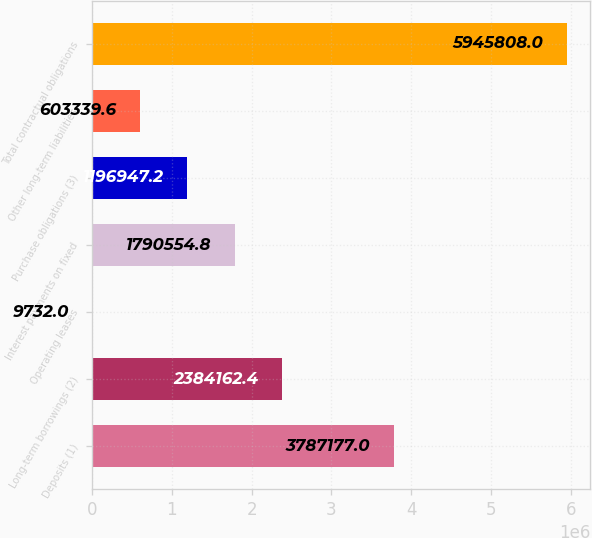Convert chart to OTSL. <chart><loc_0><loc_0><loc_500><loc_500><bar_chart><fcel>Deposits (1)<fcel>Long-term borrowings (2)<fcel>Operating leases<fcel>Interest payments on fixed<fcel>Purchase obligations (3)<fcel>Other long-term liabilities<fcel>Total contractual obligations<nl><fcel>3.78718e+06<fcel>2.38416e+06<fcel>9732<fcel>1.79055e+06<fcel>1.19695e+06<fcel>603340<fcel>5.94581e+06<nl></chart> 